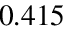<formula> <loc_0><loc_0><loc_500><loc_500>0 . 4 1 5</formula> 